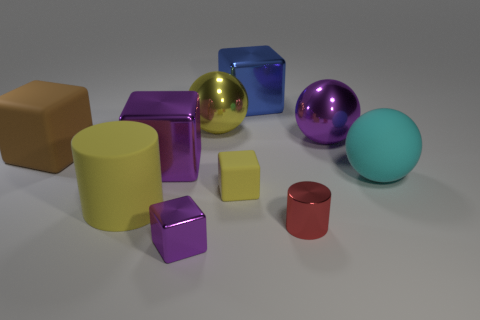Subtract all cyan balls. How many purple cubes are left? 2 Subtract 1 spheres. How many spheres are left? 2 Subtract all brown cubes. How many cubes are left? 4 Subtract all large matte cubes. How many cubes are left? 4 Subtract all brown blocks. Subtract all green cylinders. How many blocks are left? 4 Subtract all cylinders. How many objects are left? 8 Add 6 small purple metal cubes. How many small purple metal cubes are left? 7 Add 4 blue metal blocks. How many blue metal blocks exist? 5 Subtract 0 brown balls. How many objects are left? 10 Subtract all big cylinders. Subtract all large yellow shiny things. How many objects are left? 8 